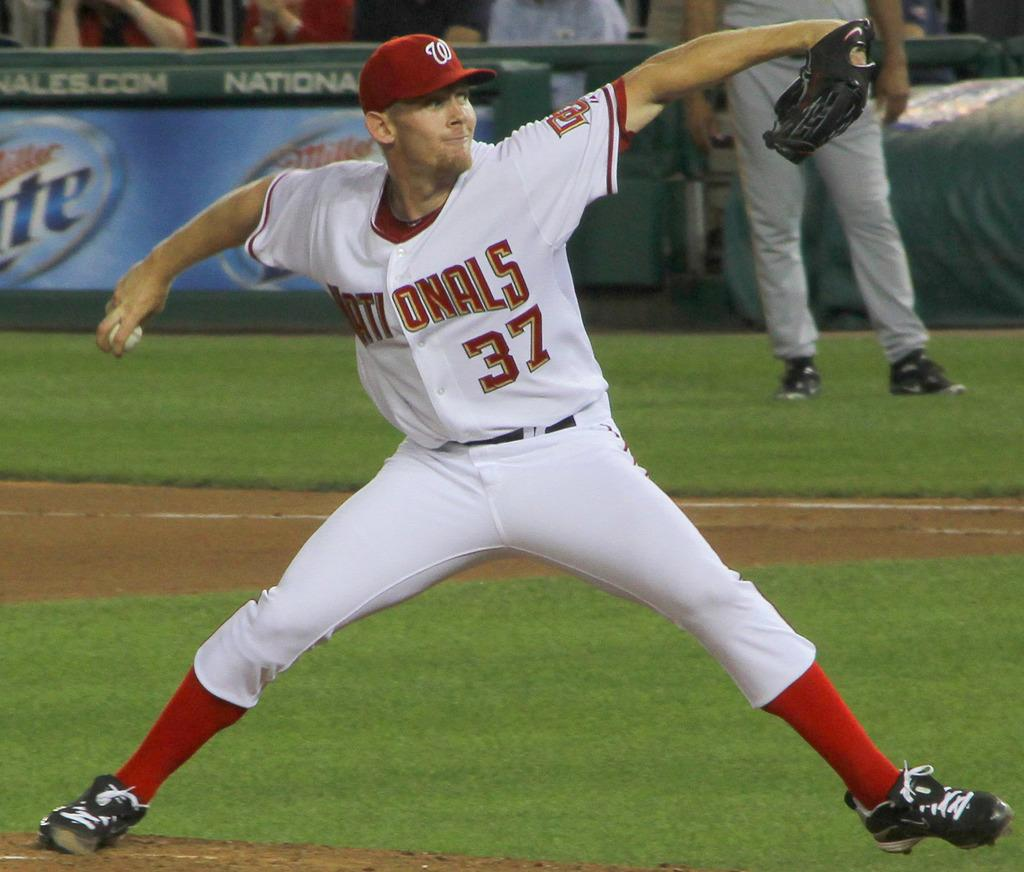<image>
Create a compact narrative representing the image presented. A baseball player for the Nationals pitching with his right hand. 